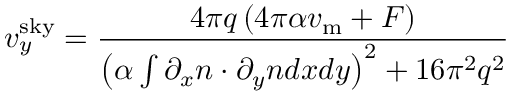<formula> <loc_0><loc_0><loc_500><loc_500>v _ { y } ^ { s k y } = \frac { 4 \pi q \left ( 4 \pi \alpha v _ { m } + F \right ) } { \left ( \alpha \int { \partial _ { x } n \cdot \partial _ { y } n d x d y } \right ) ^ { 2 } + 1 6 \pi ^ { 2 } q ^ { 2 } }</formula> 